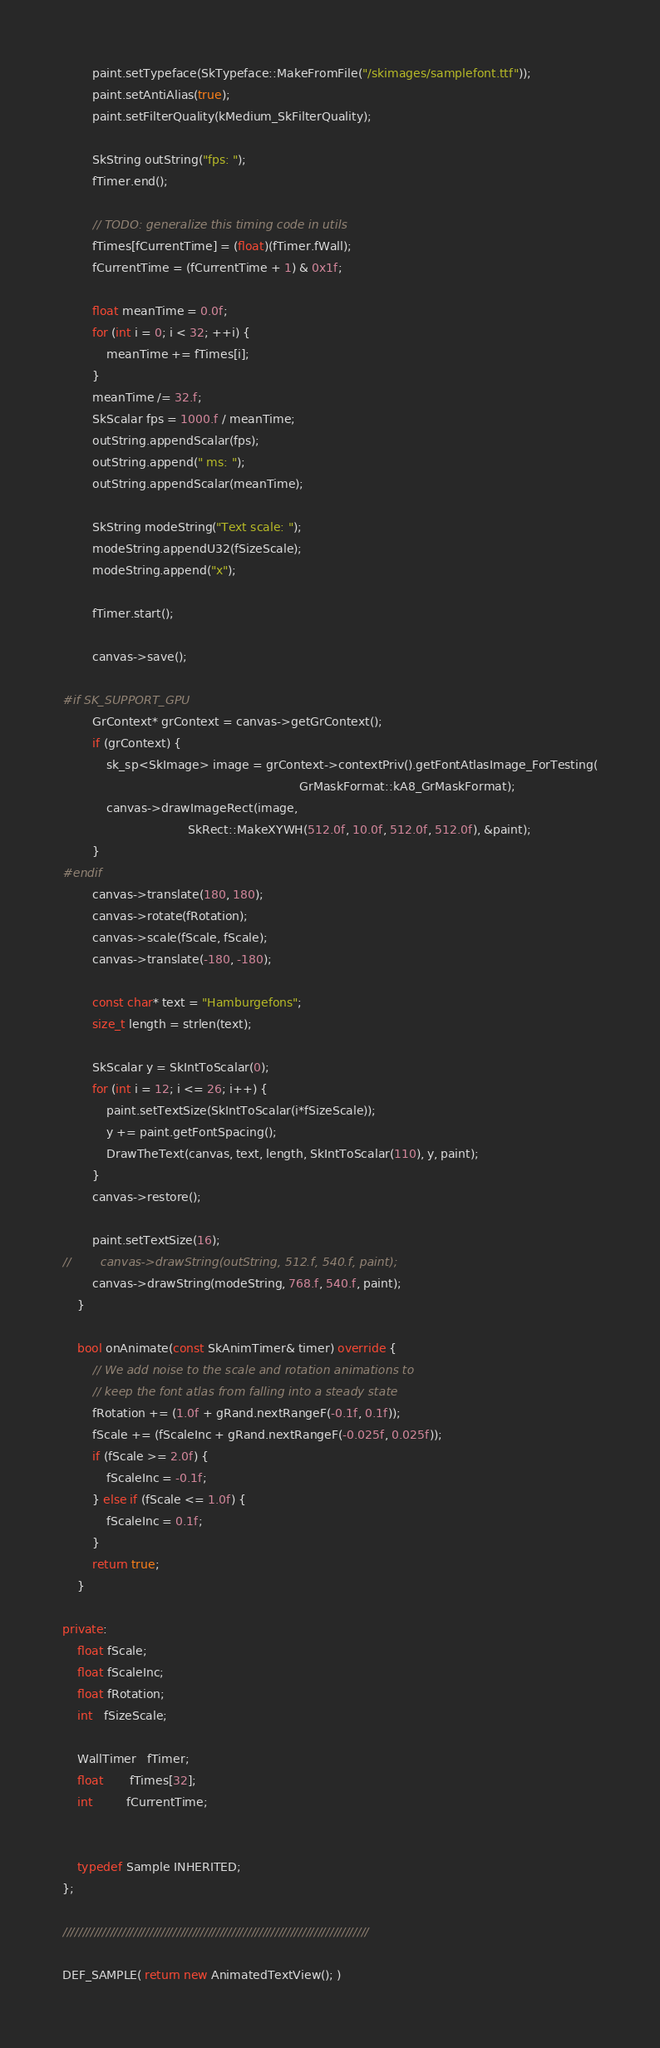<code> <loc_0><loc_0><loc_500><loc_500><_C++_>        paint.setTypeface(SkTypeface::MakeFromFile("/skimages/samplefont.ttf"));
        paint.setAntiAlias(true);
        paint.setFilterQuality(kMedium_SkFilterQuality);

        SkString outString("fps: ");
        fTimer.end();

        // TODO: generalize this timing code in utils
        fTimes[fCurrentTime] = (float)(fTimer.fWall);
        fCurrentTime = (fCurrentTime + 1) & 0x1f;

        float meanTime = 0.0f;
        for (int i = 0; i < 32; ++i) {
            meanTime += fTimes[i];
        }
        meanTime /= 32.f;
        SkScalar fps = 1000.f / meanTime;
        outString.appendScalar(fps);
        outString.append(" ms: ");
        outString.appendScalar(meanTime);

        SkString modeString("Text scale: ");
        modeString.appendU32(fSizeScale);
        modeString.append("x");

        fTimer.start();

        canvas->save();

#if SK_SUPPORT_GPU
        GrContext* grContext = canvas->getGrContext();
        if (grContext) {
            sk_sp<SkImage> image = grContext->contextPriv().getFontAtlasImage_ForTesting(
                                                                GrMaskFormat::kA8_GrMaskFormat);
            canvas->drawImageRect(image,
                                  SkRect::MakeXYWH(512.0f, 10.0f, 512.0f, 512.0f), &paint);
        }
#endif
        canvas->translate(180, 180);
        canvas->rotate(fRotation);
        canvas->scale(fScale, fScale);
        canvas->translate(-180, -180);

        const char* text = "Hamburgefons";
        size_t length = strlen(text);

        SkScalar y = SkIntToScalar(0);
        for (int i = 12; i <= 26; i++) {
            paint.setTextSize(SkIntToScalar(i*fSizeScale));
            y += paint.getFontSpacing();
            DrawTheText(canvas, text, length, SkIntToScalar(110), y, paint);
        }
        canvas->restore();

        paint.setTextSize(16);
//        canvas->drawString(outString, 512.f, 540.f, paint);
        canvas->drawString(modeString, 768.f, 540.f, paint);
    }

    bool onAnimate(const SkAnimTimer& timer) override {
        // We add noise to the scale and rotation animations to
        // keep the font atlas from falling into a steady state
        fRotation += (1.0f + gRand.nextRangeF(-0.1f, 0.1f));
        fScale += (fScaleInc + gRand.nextRangeF(-0.025f, 0.025f));
        if (fScale >= 2.0f) {
            fScaleInc = -0.1f;
        } else if (fScale <= 1.0f) {
            fScaleInc = 0.1f;
        }
        return true;
    }

private:
    float fScale;
    float fScaleInc;
    float fRotation;
    int   fSizeScale;

    WallTimer   fTimer;
    float       fTimes[32];
    int         fCurrentTime;


    typedef Sample INHERITED;
};

//////////////////////////////////////////////////////////////////////////////

DEF_SAMPLE( return new AnimatedTextView(); )
</code> 